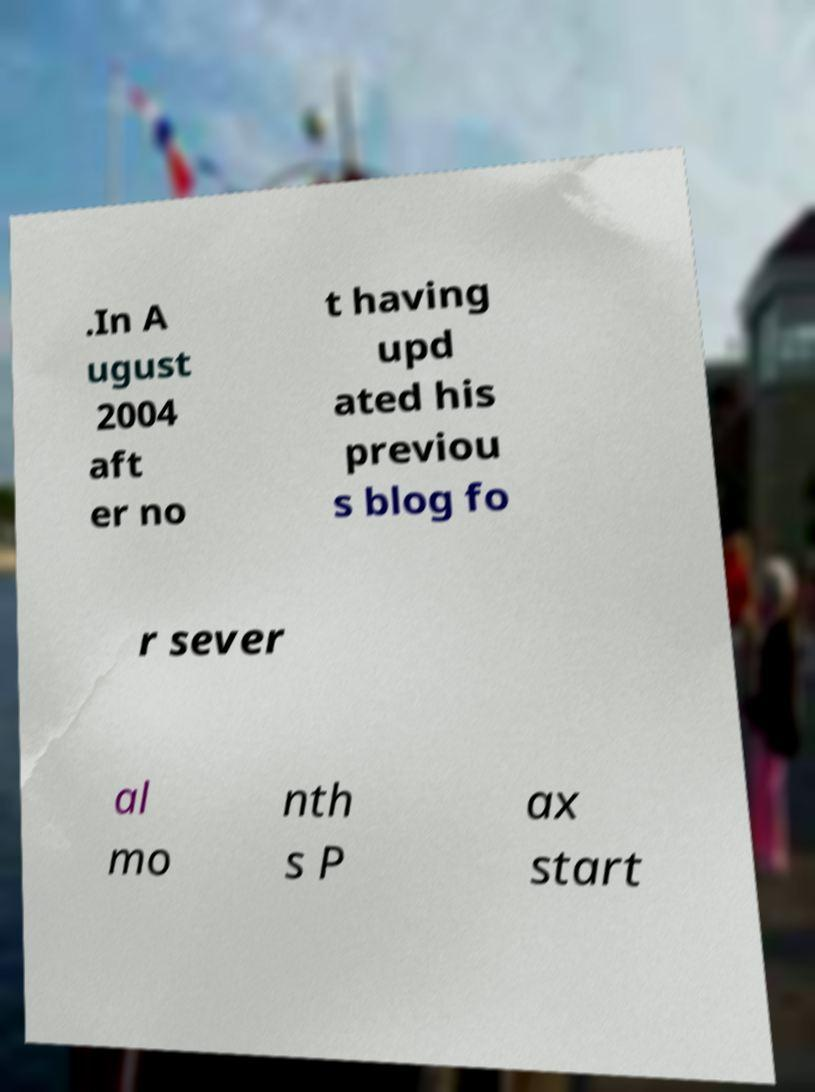For documentation purposes, I need the text within this image transcribed. Could you provide that? .In A ugust 2004 aft er no t having upd ated his previou s blog fo r sever al mo nth s P ax start 